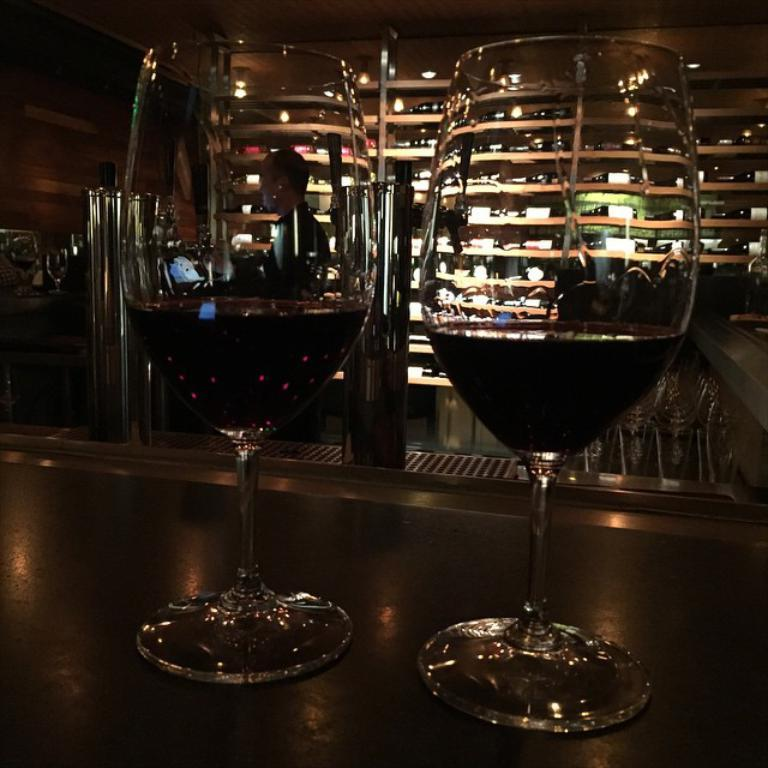What objects in the image contain liquid? There are two glasses with liquid in the image. Where are the glasses with liquid located? The glasses are on a table. What can be seen in the background of the image? There are shelves in the background of the image. Who is present in the image? There is a person in the image. What type of furniture is visible in the image? There are chairs in the image. What is the title of the book the person is reading in the image? There is no book or reading activity depicted in the image. What type of airplane can be seen flying in the background of the image? There is no airplane present in the image; it only features a table, glasses with liquid, shelves, a person, and chairs. 